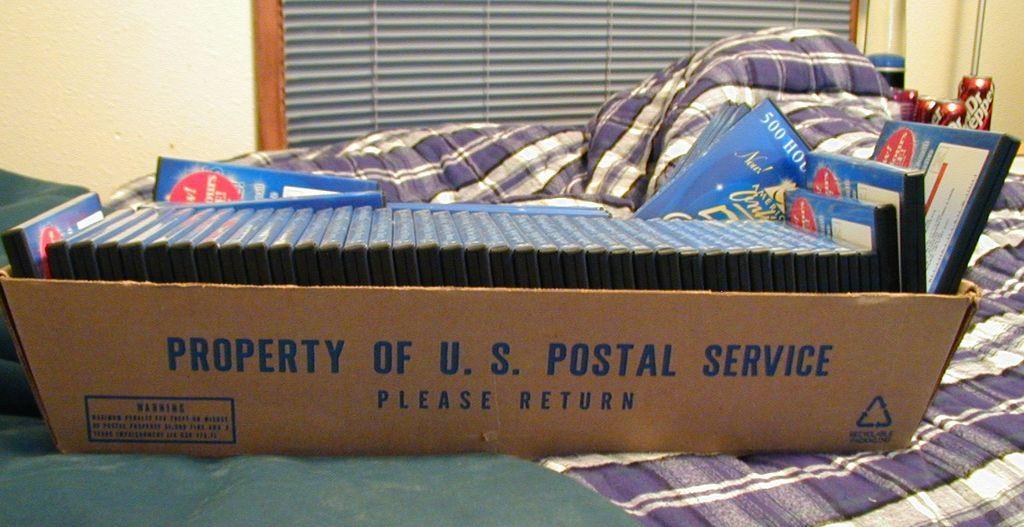In one or two sentences, can you explain what this image depicts? In this image we can see a cardboard carton filled with discs and places on the cot. In the background there are blinds, walls and beverage tins. 